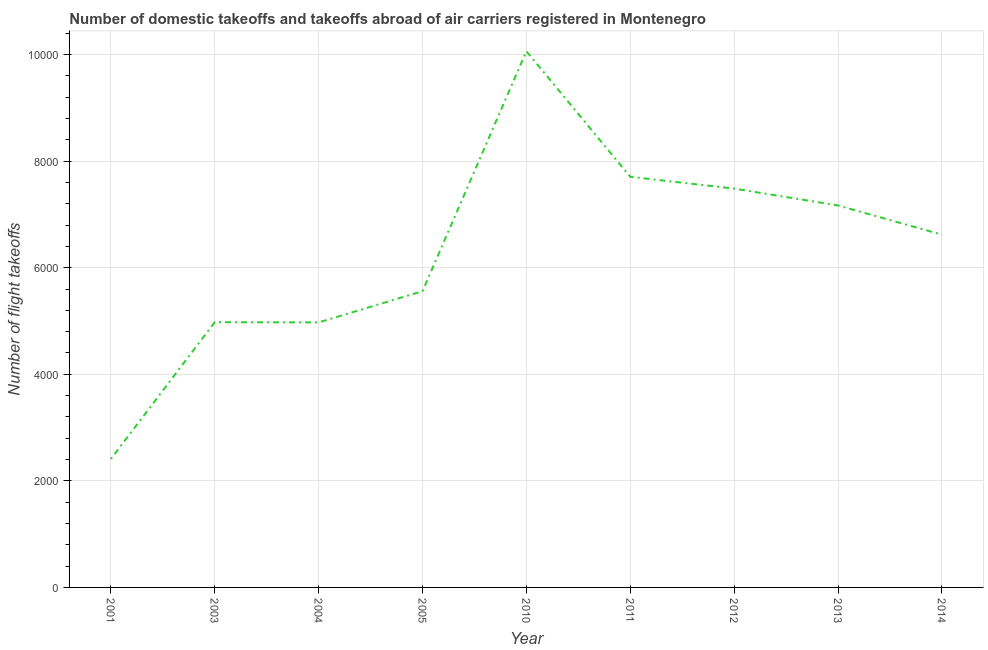What is the number of flight takeoffs in 2011?
Make the answer very short. 7707. Across all years, what is the maximum number of flight takeoffs?
Offer a terse response. 1.01e+04. Across all years, what is the minimum number of flight takeoffs?
Make the answer very short. 2411. In which year was the number of flight takeoffs maximum?
Offer a terse response. 2010. What is the sum of the number of flight takeoffs?
Your answer should be very brief. 5.70e+04. What is the difference between the number of flight takeoffs in 2003 and 2012?
Give a very brief answer. -2507. What is the average number of flight takeoffs per year?
Provide a short and direct response. 6329.87. What is the median number of flight takeoffs?
Your answer should be very brief. 6620.78. In how many years, is the number of flight takeoffs greater than 1200 ?
Give a very brief answer. 9. Do a majority of the years between 2012 and 2005 (inclusive) have number of flight takeoffs greater than 2800 ?
Offer a terse response. Yes. What is the ratio of the number of flight takeoffs in 2003 to that in 2010?
Your response must be concise. 0.49. Is the difference between the number of flight takeoffs in 2003 and 2004 greater than the difference between any two years?
Ensure brevity in your answer.  No. What is the difference between the highest and the second highest number of flight takeoffs?
Provide a succinct answer. 2357.01. What is the difference between the highest and the lowest number of flight takeoffs?
Offer a terse response. 7653.01. In how many years, is the number of flight takeoffs greater than the average number of flight takeoffs taken over all years?
Your answer should be compact. 5. Does the graph contain grids?
Make the answer very short. Yes. What is the title of the graph?
Make the answer very short. Number of domestic takeoffs and takeoffs abroad of air carriers registered in Montenegro. What is the label or title of the Y-axis?
Ensure brevity in your answer.  Number of flight takeoffs. What is the Number of flight takeoffs of 2001?
Provide a short and direct response. 2411. What is the Number of flight takeoffs in 2003?
Provide a short and direct response. 4978. What is the Number of flight takeoffs in 2004?
Your answer should be very brief. 4974. What is the Number of flight takeoffs of 2005?
Your answer should be very brief. 5560. What is the Number of flight takeoffs of 2010?
Your answer should be very brief. 1.01e+04. What is the Number of flight takeoffs in 2011?
Ensure brevity in your answer.  7707. What is the Number of flight takeoffs of 2012?
Make the answer very short. 7485. What is the Number of flight takeoffs of 2013?
Make the answer very short. 7169. What is the Number of flight takeoffs of 2014?
Offer a terse response. 6620.78. What is the difference between the Number of flight takeoffs in 2001 and 2003?
Your response must be concise. -2567. What is the difference between the Number of flight takeoffs in 2001 and 2004?
Your response must be concise. -2563. What is the difference between the Number of flight takeoffs in 2001 and 2005?
Provide a short and direct response. -3149. What is the difference between the Number of flight takeoffs in 2001 and 2010?
Your answer should be very brief. -7653.01. What is the difference between the Number of flight takeoffs in 2001 and 2011?
Ensure brevity in your answer.  -5296. What is the difference between the Number of flight takeoffs in 2001 and 2012?
Offer a very short reply. -5074. What is the difference between the Number of flight takeoffs in 2001 and 2013?
Keep it short and to the point. -4758. What is the difference between the Number of flight takeoffs in 2001 and 2014?
Keep it short and to the point. -4209.78. What is the difference between the Number of flight takeoffs in 2003 and 2005?
Keep it short and to the point. -582. What is the difference between the Number of flight takeoffs in 2003 and 2010?
Give a very brief answer. -5086.01. What is the difference between the Number of flight takeoffs in 2003 and 2011?
Your answer should be compact. -2729. What is the difference between the Number of flight takeoffs in 2003 and 2012?
Your response must be concise. -2507. What is the difference between the Number of flight takeoffs in 2003 and 2013?
Keep it short and to the point. -2191. What is the difference between the Number of flight takeoffs in 2003 and 2014?
Keep it short and to the point. -1642.78. What is the difference between the Number of flight takeoffs in 2004 and 2005?
Offer a very short reply. -586. What is the difference between the Number of flight takeoffs in 2004 and 2010?
Your response must be concise. -5090.01. What is the difference between the Number of flight takeoffs in 2004 and 2011?
Provide a short and direct response. -2733. What is the difference between the Number of flight takeoffs in 2004 and 2012?
Ensure brevity in your answer.  -2511. What is the difference between the Number of flight takeoffs in 2004 and 2013?
Your answer should be very brief. -2195. What is the difference between the Number of flight takeoffs in 2004 and 2014?
Your response must be concise. -1646.78. What is the difference between the Number of flight takeoffs in 2005 and 2010?
Give a very brief answer. -4504.01. What is the difference between the Number of flight takeoffs in 2005 and 2011?
Offer a very short reply. -2147. What is the difference between the Number of flight takeoffs in 2005 and 2012?
Make the answer very short. -1925. What is the difference between the Number of flight takeoffs in 2005 and 2013?
Your answer should be compact. -1609. What is the difference between the Number of flight takeoffs in 2005 and 2014?
Give a very brief answer. -1060.78. What is the difference between the Number of flight takeoffs in 2010 and 2011?
Your answer should be very brief. 2357.01. What is the difference between the Number of flight takeoffs in 2010 and 2012?
Provide a succinct answer. 2579.01. What is the difference between the Number of flight takeoffs in 2010 and 2013?
Make the answer very short. 2895.01. What is the difference between the Number of flight takeoffs in 2010 and 2014?
Provide a short and direct response. 3443.23. What is the difference between the Number of flight takeoffs in 2011 and 2012?
Give a very brief answer. 222. What is the difference between the Number of flight takeoffs in 2011 and 2013?
Make the answer very short. 538. What is the difference between the Number of flight takeoffs in 2011 and 2014?
Ensure brevity in your answer.  1086.22. What is the difference between the Number of flight takeoffs in 2012 and 2013?
Give a very brief answer. 316. What is the difference between the Number of flight takeoffs in 2012 and 2014?
Provide a short and direct response. 864.22. What is the difference between the Number of flight takeoffs in 2013 and 2014?
Provide a succinct answer. 548.22. What is the ratio of the Number of flight takeoffs in 2001 to that in 2003?
Offer a terse response. 0.48. What is the ratio of the Number of flight takeoffs in 2001 to that in 2004?
Your answer should be very brief. 0.48. What is the ratio of the Number of flight takeoffs in 2001 to that in 2005?
Keep it short and to the point. 0.43. What is the ratio of the Number of flight takeoffs in 2001 to that in 2010?
Provide a short and direct response. 0.24. What is the ratio of the Number of flight takeoffs in 2001 to that in 2011?
Give a very brief answer. 0.31. What is the ratio of the Number of flight takeoffs in 2001 to that in 2012?
Provide a succinct answer. 0.32. What is the ratio of the Number of flight takeoffs in 2001 to that in 2013?
Your answer should be compact. 0.34. What is the ratio of the Number of flight takeoffs in 2001 to that in 2014?
Your response must be concise. 0.36. What is the ratio of the Number of flight takeoffs in 2003 to that in 2004?
Your answer should be compact. 1. What is the ratio of the Number of flight takeoffs in 2003 to that in 2005?
Offer a very short reply. 0.9. What is the ratio of the Number of flight takeoffs in 2003 to that in 2010?
Offer a terse response. 0.49. What is the ratio of the Number of flight takeoffs in 2003 to that in 2011?
Ensure brevity in your answer.  0.65. What is the ratio of the Number of flight takeoffs in 2003 to that in 2012?
Give a very brief answer. 0.67. What is the ratio of the Number of flight takeoffs in 2003 to that in 2013?
Keep it short and to the point. 0.69. What is the ratio of the Number of flight takeoffs in 2003 to that in 2014?
Ensure brevity in your answer.  0.75. What is the ratio of the Number of flight takeoffs in 2004 to that in 2005?
Provide a succinct answer. 0.9. What is the ratio of the Number of flight takeoffs in 2004 to that in 2010?
Your response must be concise. 0.49. What is the ratio of the Number of flight takeoffs in 2004 to that in 2011?
Your answer should be very brief. 0.65. What is the ratio of the Number of flight takeoffs in 2004 to that in 2012?
Provide a succinct answer. 0.67. What is the ratio of the Number of flight takeoffs in 2004 to that in 2013?
Offer a very short reply. 0.69. What is the ratio of the Number of flight takeoffs in 2004 to that in 2014?
Give a very brief answer. 0.75. What is the ratio of the Number of flight takeoffs in 2005 to that in 2010?
Provide a succinct answer. 0.55. What is the ratio of the Number of flight takeoffs in 2005 to that in 2011?
Keep it short and to the point. 0.72. What is the ratio of the Number of flight takeoffs in 2005 to that in 2012?
Ensure brevity in your answer.  0.74. What is the ratio of the Number of flight takeoffs in 2005 to that in 2013?
Provide a short and direct response. 0.78. What is the ratio of the Number of flight takeoffs in 2005 to that in 2014?
Provide a short and direct response. 0.84. What is the ratio of the Number of flight takeoffs in 2010 to that in 2011?
Provide a succinct answer. 1.31. What is the ratio of the Number of flight takeoffs in 2010 to that in 2012?
Provide a short and direct response. 1.34. What is the ratio of the Number of flight takeoffs in 2010 to that in 2013?
Offer a very short reply. 1.4. What is the ratio of the Number of flight takeoffs in 2010 to that in 2014?
Provide a short and direct response. 1.52. What is the ratio of the Number of flight takeoffs in 2011 to that in 2013?
Provide a succinct answer. 1.07. What is the ratio of the Number of flight takeoffs in 2011 to that in 2014?
Ensure brevity in your answer.  1.16. What is the ratio of the Number of flight takeoffs in 2012 to that in 2013?
Give a very brief answer. 1.04. What is the ratio of the Number of flight takeoffs in 2012 to that in 2014?
Make the answer very short. 1.13. What is the ratio of the Number of flight takeoffs in 2013 to that in 2014?
Your answer should be compact. 1.08. 